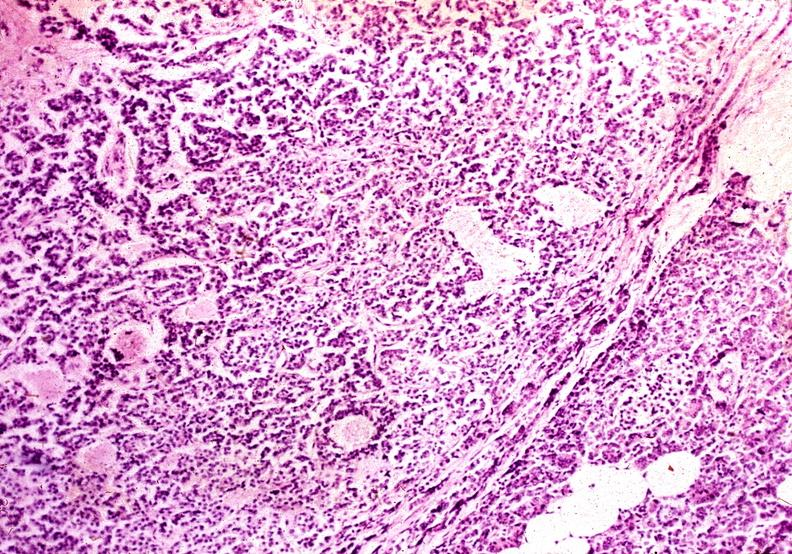what does this image show?
Answer the question using a single word or phrase. Islet cell carcinoma 